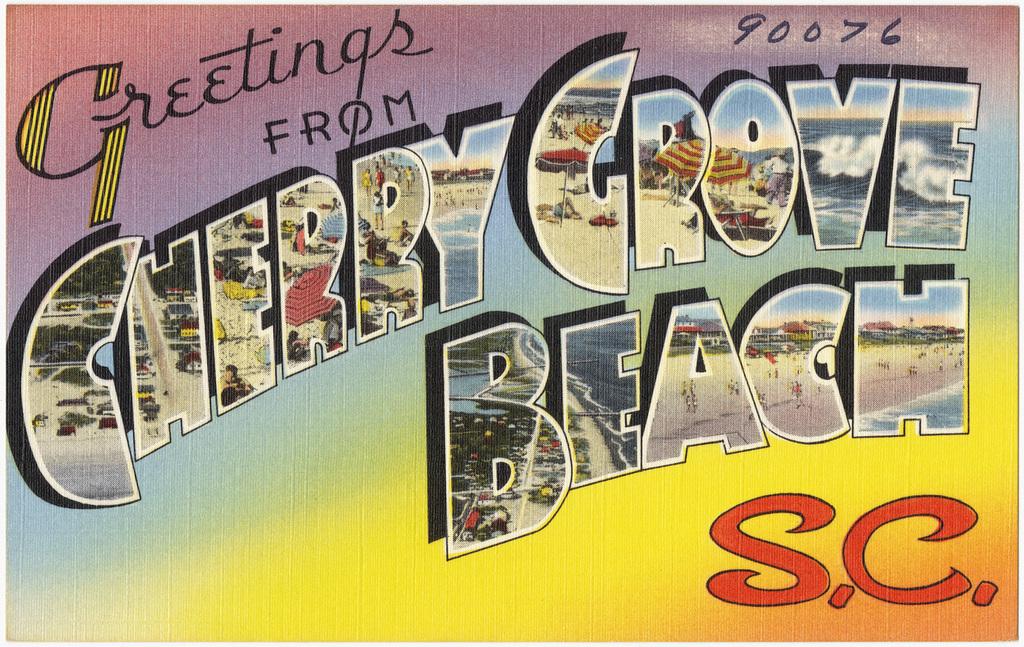What is the name of the beach?
Make the answer very short. Cherry grove. 